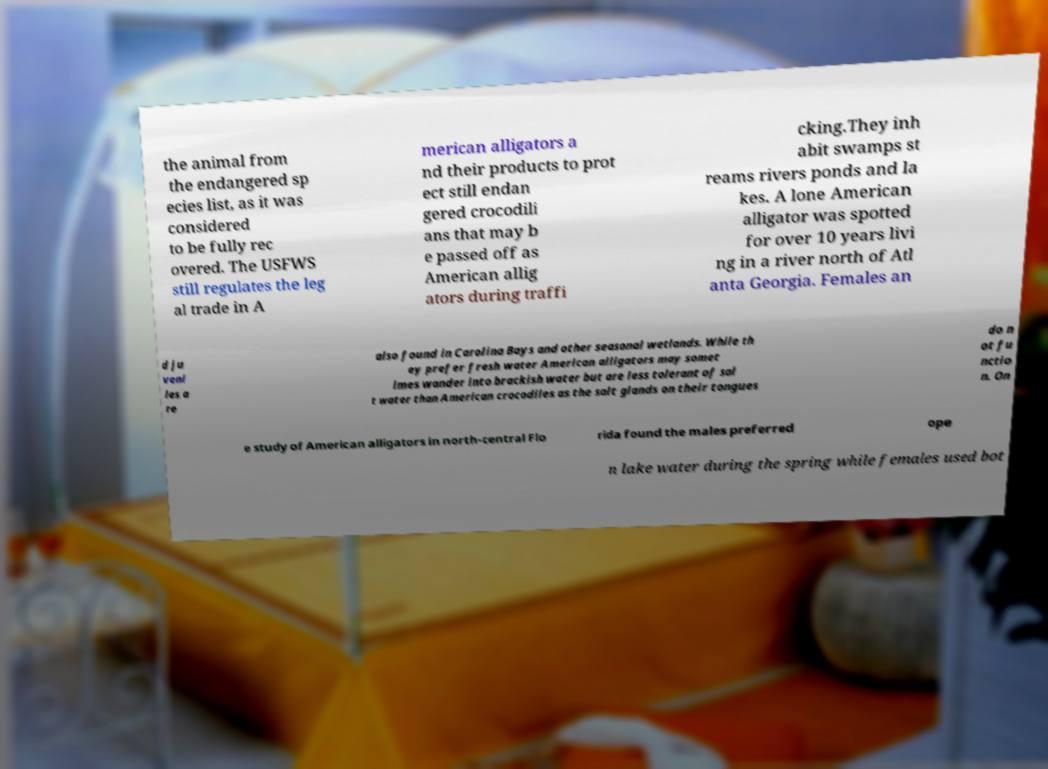Can you accurately transcribe the text from the provided image for me? the animal from the endangered sp ecies list, as it was considered to be fully rec overed. The USFWS still regulates the leg al trade in A merican alligators a nd their products to prot ect still endan gered crocodili ans that may b e passed off as American allig ators during traffi cking.They inh abit swamps st reams rivers ponds and la kes. A lone American alligator was spotted for over 10 years livi ng in a river north of Atl anta Georgia. Females an d ju veni les a re also found in Carolina Bays and other seasonal wetlands. While th ey prefer fresh water American alligators may somet imes wander into brackish water but are less tolerant of sal t water than American crocodiles as the salt glands on their tongues do n ot fu nctio n. On e study of American alligators in north-central Flo rida found the males preferred ope n lake water during the spring while females used bot 